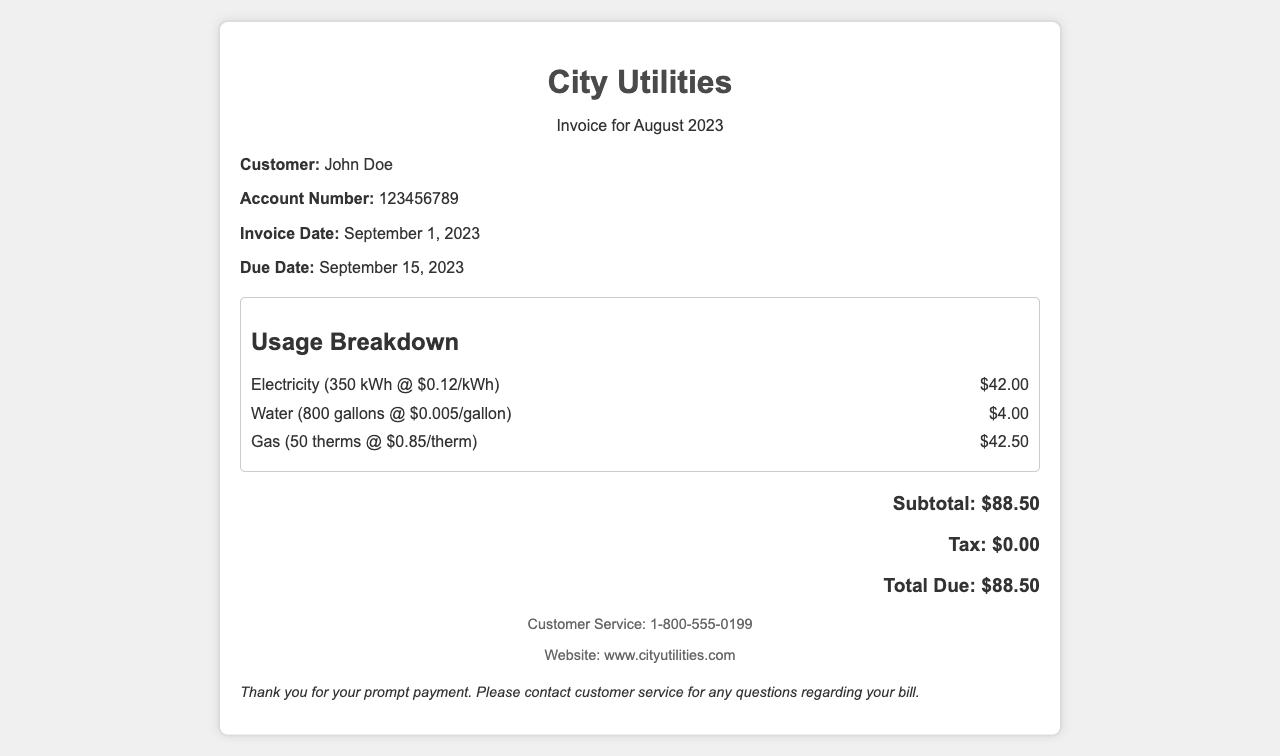What is the total due for this invoice? The total due is specified at the end of the invoice, which is $88.50.
Answer: $88.50 Who is the customer listed on the invoice? The customer name is stated in the customer info section, which is John Doe.
Answer: John Doe What is the account number on this invoice? The account number is included in the customer info section, which is 123456789.
Answer: 123456789 When is the due date for the payment? The due date is found in the customer info section, which is September 15, 2023.
Answer: September 15, 2023 What is the charge for electricity? The charge for electricity is detailed in the usage breakdown, which is $42.00.
Answer: $42.00 How much is charged per gallon of water? The charge per gallon of water is shown in the usage breakdown, which is $0.005.
Answer: $0.005 What type of document is this? The document clearly states in the header that it is a City Utilities Invoice.
Answer: Invoice What is the subtotal for the charges? The subtotal is outlined in the total section, which is $88.50.
Answer: $88.50 How many therms of gas were used? The quantity of gas used is specified in the usage breakdown, which is 50 therms.
Answer: 50 therms 